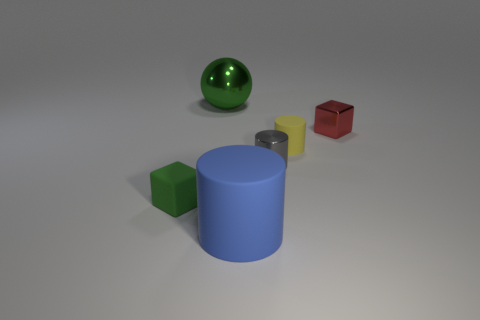There is a matte object that is the same color as the large metal thing; what size is it?
Provide a succinct answer. Small. Is there a cyan sphere of the same size as the yellow cylinder?
Give a very brief answer. No. Does the block on the right side of the tiny green thing have the same color as the rubber object on the right side of the big blue rubber object?
Keep it short and to the point. No. Is there a big object that has the same color as the large rubber cylinder?
Make the answer very short. No. How many other things are there of the same shape as the green matte object?
Offer a terse response. 1. What is the shape of the green object that is on the left side of the large ball?
Give a very brief answer. Cube. There is a big green shiny object; is it the same shape as the big object that is in front of the small yellow rubber thing?
Your response must be concise. No. There is a object that is in front of the large green shiny thing and behind the small yellow cylinder; how big is it?
Provide a succinct answer. Small. What color is the matte thing that is behind the big cylinder and to the right of the matte block?
Provide a succinct answer. Yellow. Are there any other things that have the same material as the red thing?
Your answer should be compact. Yes. 